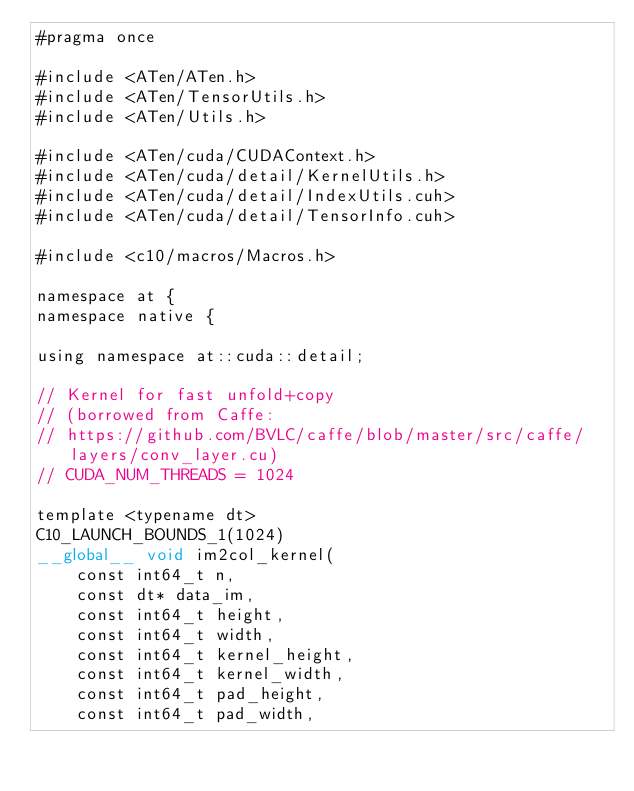Convert code to text. <code><loc_0><loc_0><loc_500><loc_500><_Cuda_>#pragma once

#include <ATen/ATen.h>
#include <ATen/TensorUtils.h>
#include <ATen/Utils.h>

#include <ATen/cuda/CUDAContext.h>
#include <ATen/cuda/detail/KernelUtils.h>
#include <ATen/cuda/detail/IndexUtils.cuh>
#include <ATen/cuda/detail/TensorInfo.cuh>

#include <c10/macros/Macros.h>

namespace at {
namespace native {

using namespace at::cuda::detail;

// Kernel for fast unfold+copy
// (borrowed from Caffe:
// https://github.com/BVLC/caffe/blob/master/src/caffe/layers/conv_layer.cu)
// CUDA_NUM_THREADS = 1024

template <typename dt>
C10_LAUNCH_BOUNDS_1(1024)
__global__ void im2col_kernel(
    const int64_t n,
    const dt* data_im,
    const int64_t height,
    const int64_t width,
    const int64_t kernel_height,
    const int64_t kernel_width,
    const int64_t pad_height,
    const int64_t pad_width,</code> 